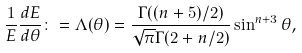<formula> <loc_0><loc_0><loc_500><loc_500>\frac { 1 } { E } \frac { d E } { d \theta } \colon = \Lambda ( \theta ) = \frac { \Gamma ( ( n + 5 ) / 2 ) } { \sqrt { \pi } \Gamma ( 2 + n / 2 ) } \sin ^ { n + 3 } \theta ,</formula> 